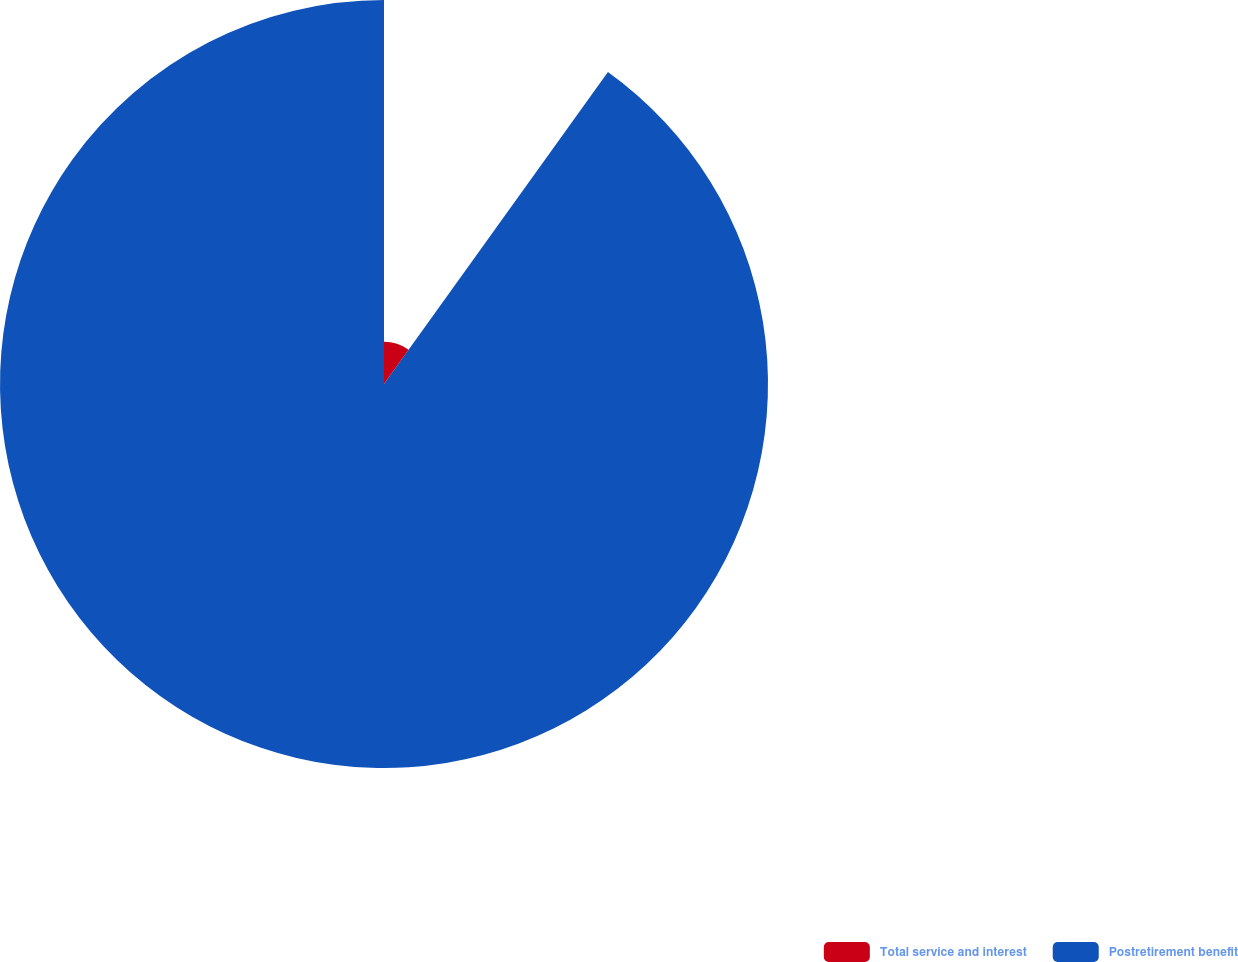Convert chart to OTSL. <chart><loc_0><loc_0><loc_500><loc_500><pie_chart><fcel>Total service and interest<fcel>Postretirement benefit<nl><fcel>9.91%<fcel>90.09%<nl></chart> 